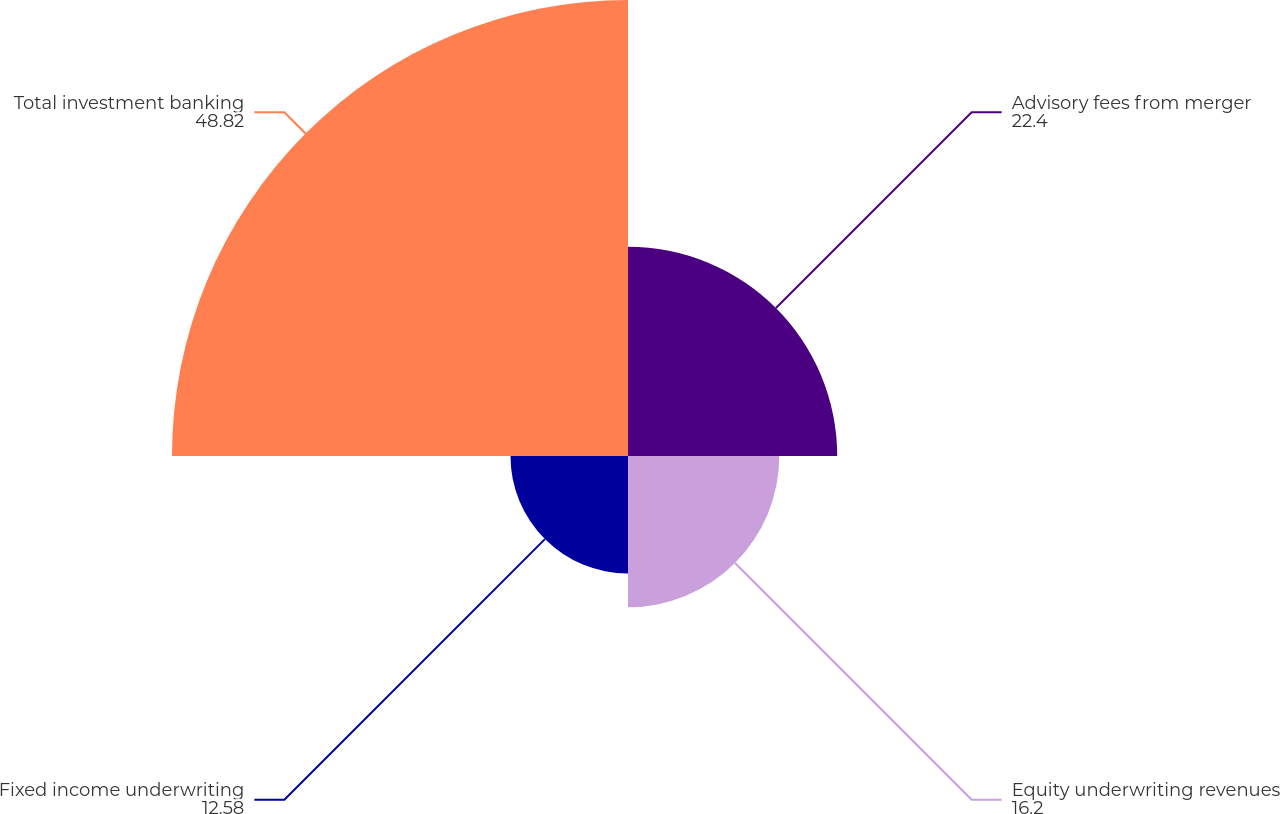Convert chart to OTSL. <chart><loc_0><loc_0><loc_500><loc_500><pie_chart><fcel>Advisory fees from merger<fcel>Equity underwriting revenues<fcel>Fixed income underwriting<fcel>Total investment banking<nl><fcel>22.4%<fcel>16.2%<fcel>12.58%<fcel>48.82%<nl></chart> 